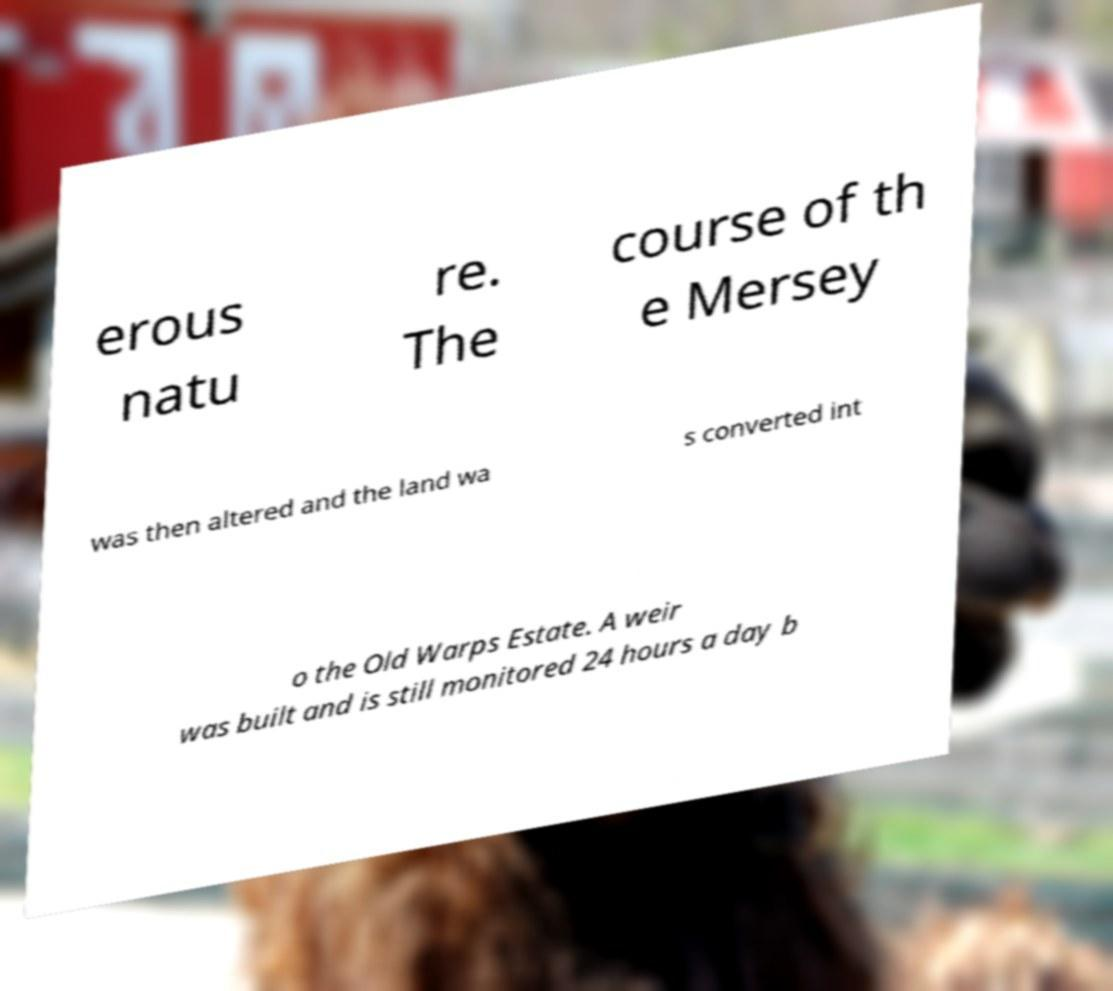Can you accurately transcribe the text from the provided image for me? erous natu re. The course of th e Mersey was then altered and the land wa s converted int o the Old Warps Estate. A weir was built and is still monitored 24 hours a day b 